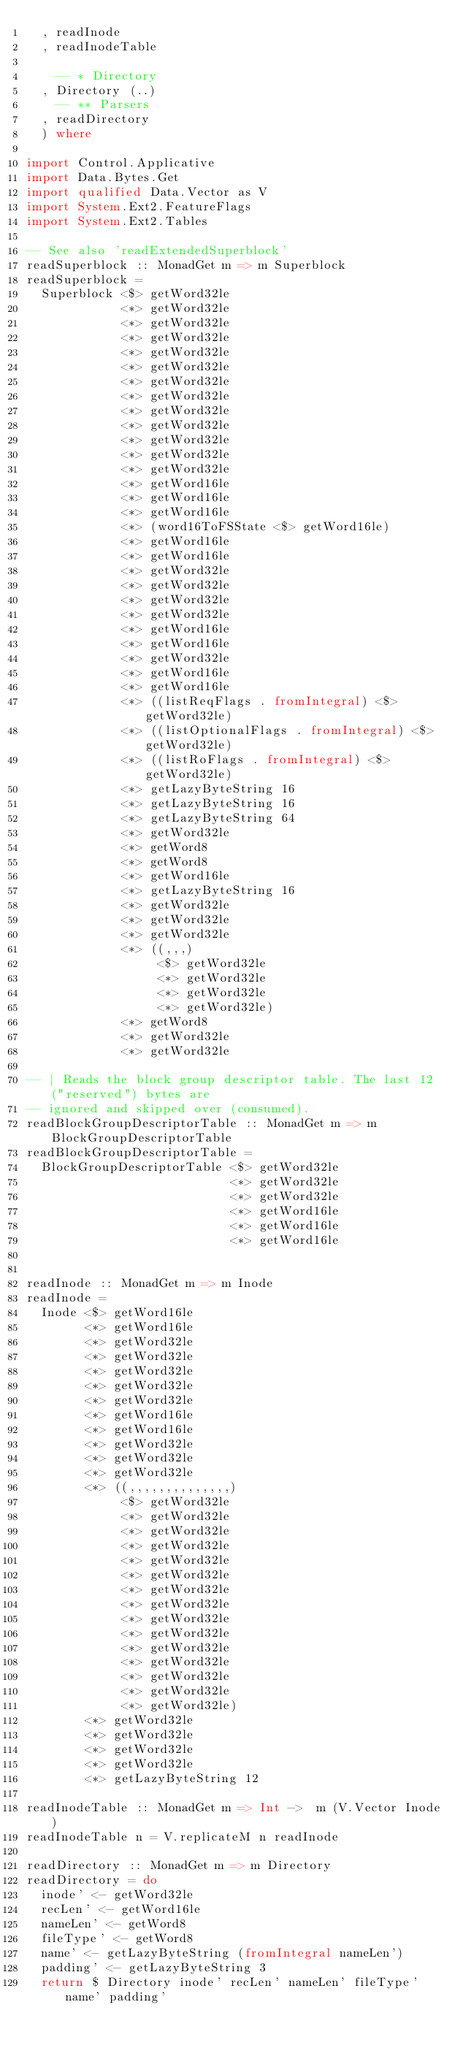Convert code to text. <code><loc_0><loc_0><loc_500><loc_500><_Haskell_>  , readInode
  , readInodeTable

    -- * Directory
  , Directory (..)
    -- ** Parsers
  , readDirectory
  ) where

import Control.Applicative
import Data.Bytes.Get
import qualified Data.Vector as V
import System.Ext2.FeatureFlags
import System.Ext2.Tables

-- See also 'readExtendedSuperblock'
readSuperblock :: MonadGet m => m Superblock
readSuperblock =
  Superblock <$> getWord32le
             <*> getWord32le
             <*> getWord32le
             <*> getWord32le
             <*> getWord32le
             <*> getWord32le
             <*> getWord32le
             <*> getWord32le
             <*> getWord32le
             <*> getWord32le
             <*> getWord32le
             <*> getWord32le
             <*> getWord32le
             <*> getWord16le
             <*> getWord16le
             <*> getWord16le
             <*> (word16ToFSState <$> getWord16le)
             <*> getWord16le
             <*> getWord16le
             <*> getWord32le
             <*> getWord32le
             <*> getWord32le
             <*> getWord32le
             <*> getWord16le
             <*> getWord16le
             <*> getWord32le
             <*> getWord16le
             <*> getWord16le
             <*> ((listReqFlags . fromIntegral) <$> getWord32le)
             <*> ((listOptionalFlags . fromIntegral) <$> getWord32le)
             <*> ((listRoFlags . fromIntegral) <$> getWord32le)
             <*> getLazyByteString 16
             <*> getLazyByteString 16
             <*> getLazyByteString 64
             <*> getWord32le
             <*> getWord8
             <*> getWord8
             <*> getWord16le
             <*> getLazyByteString 16
             <*> getWord32le
             <*> getWord32le
             <*> getWord32le
             <*> ((,,,)
                  <$> getWord32le
                  <*> getWord32le
                  <*> getWord32le
                  <*> getWord32le)
             <*> getWord8
             <*> getWord32le
             <*> getWord32le

-- | Reads the block group descriptor table. The last 12 ("reserved") bytes are
-- ignored and skipped over (consumed).
readBlockGroupDescriptorTable :: MonadGet m => m BlockGroupDescriptorTable
readBlockGroupDescriptorTable =
  BlockGroupDescriptorTable <$> getWord32le
                            <*> getWord32le
                            <*> getWord32le
                            <*> getWord16le
                            <*> getWord16le
                            <*> getWord16le


readInode :: MonadGet m => m Inode
readInode =
  Inode <$> getWord16le
        <*> getWord16le
        <*> getWord32le
        <*> getWord32le
        <*> getWord32le
        <*> getWord32le
        <*> getWord32le
        <*> getWord16le
        <*> getWord16le
        <*> getWord32le
        <*> getWord32le
        <*> getWord32le
        <*> ((,,,,,,,,,,,,,,)
             <$> getWord32le
             <*> getWord32le
             <*> getWord32le
             <*> getWord32le
             <*> getWord32le
             <*> getWord32le
             <*> getWord32le
             <*> getWord32le
             <*> getWord32le
             <*> getWord32le
             <*> getWord32le
             <*> getWord32le
             <*> getWord32le
             <*> getWord32le
             <*> getWord32le)
        <*> getWord32le
        <*> getWord32le
        <*> getWord32le
        <*> getWord32le
        <*> getLazyByteString 12

readInodeTable :: MonadGet m => Int ->  m (V.Vector Inode)
readInodeTable n = V.replicateM n readInode

readDirectory :: MonadGet m => m Directory
readDirectory = do
  inode' <- getWord32le
  recLen' <- getWord16le
  nameLen' <- getWord8
  fileType' <- getWord8
  name' <- getLazyByteString (fromIntegral nameLen')
  padding' <- getLazyByteString 3
  return $ Directory inode' recLen' nameLen' fileType' name' padding'
</code> 